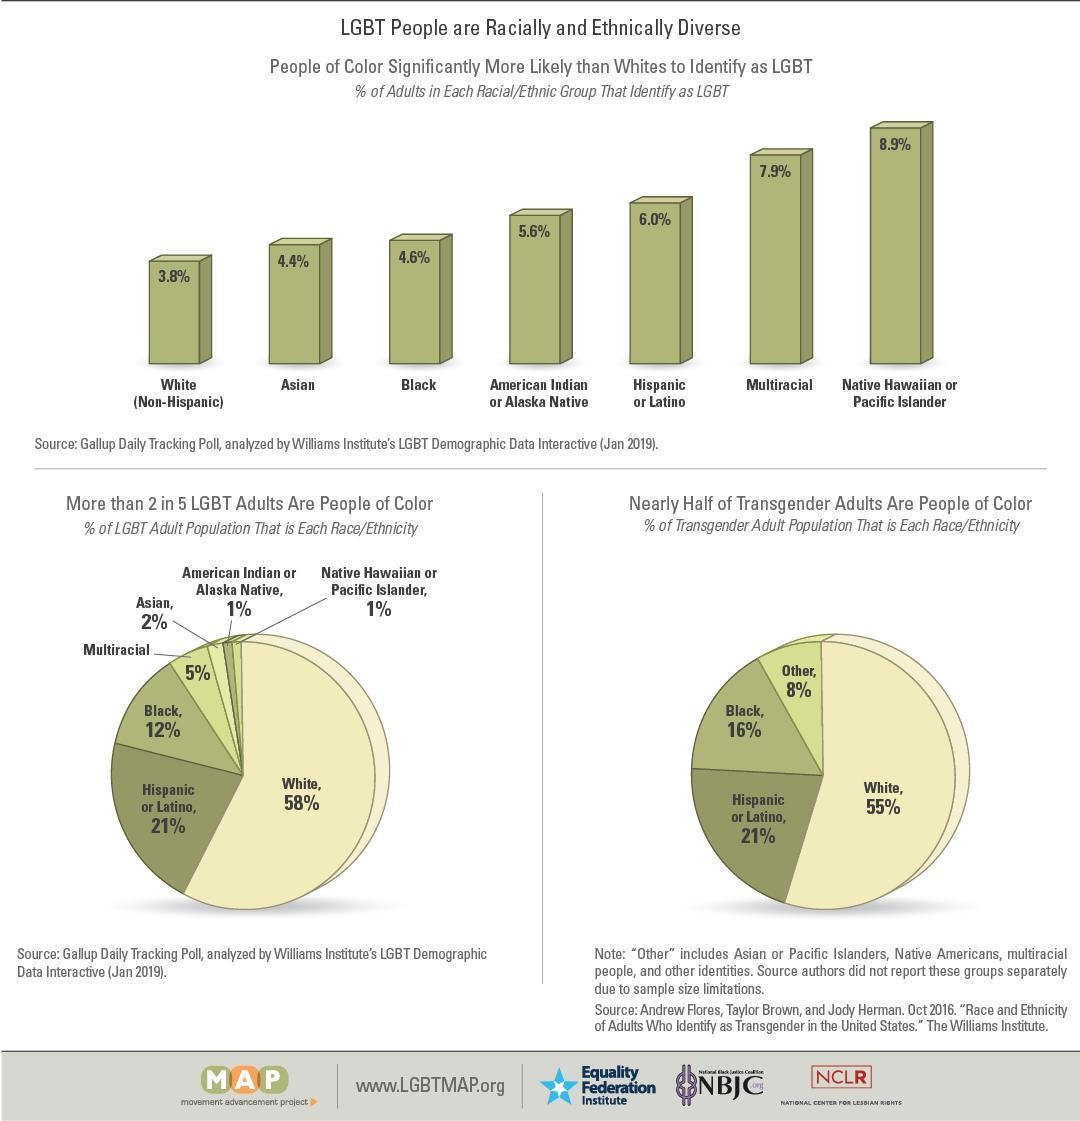Which racial group is fourth in the number of LGBT individuals in the ascending order?
Answer the question with a short phrase. American Indian or Alaska Native What percent of people constitute LGBT other than Whites as of Jan 2019? 42% What percent of LGBT adults are multiracial according to pie chart? 5% Which racial group has third highest number of people identifying as LGBT? Hispanic or Latino What percent of Blacks and Hispanic or Latino combined represent LGBT in Oct. 2016? 37% 